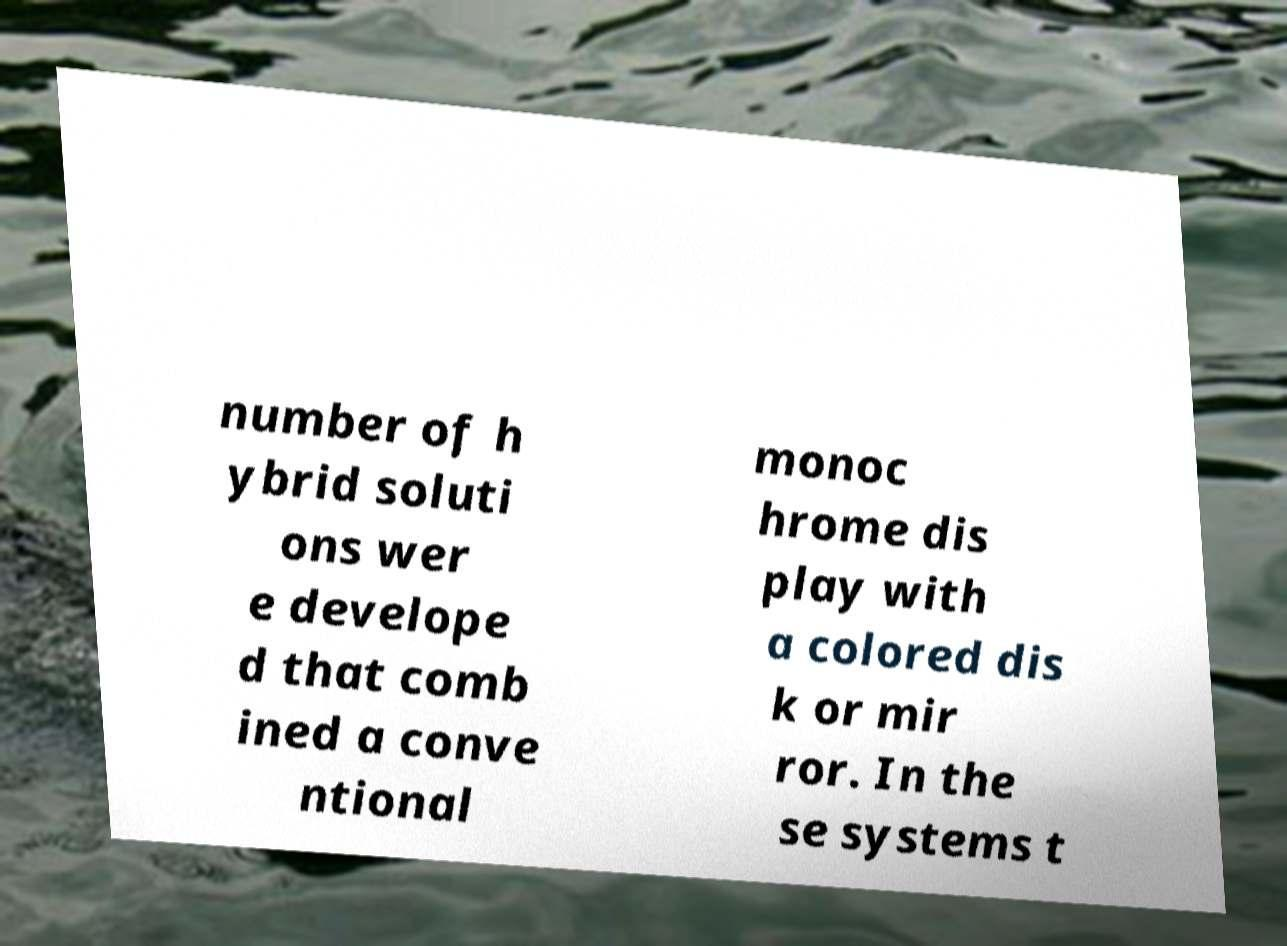For documentation purposes, I need the text within this image transcribed. Could you provide that? number of h ybrid soluti ons wer e develope d that comb ined a conve ntional monoc hrome dis play with a colored dis k or mir ror. In the se systems t 